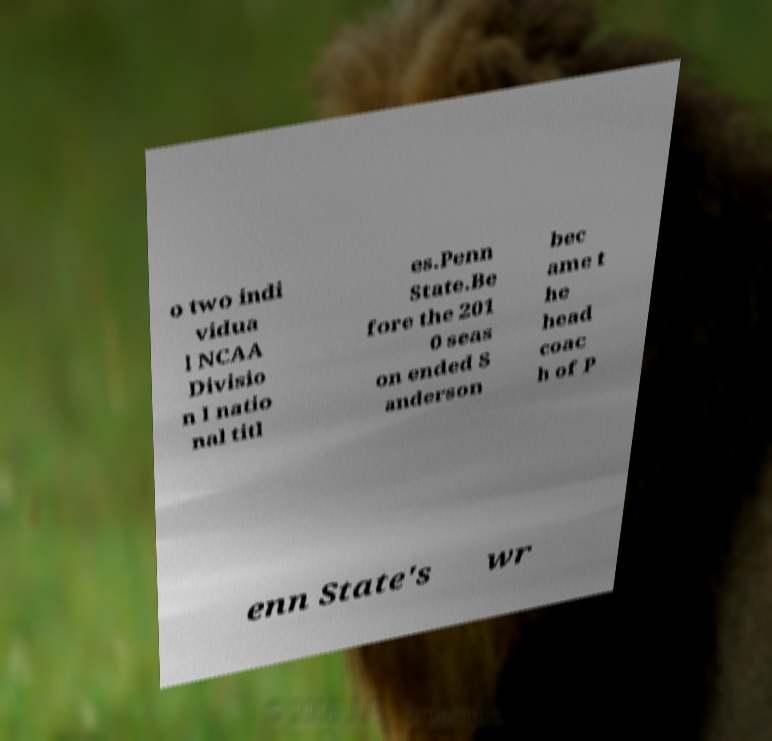Please identify and transcribe the text found in this image. o two indi vidua l NCAA Divisio n I natio nal titl es.Penn State.Be fore the 201 0 seas on ended S anderson bec ame t he head coac h of P enn State's wr 